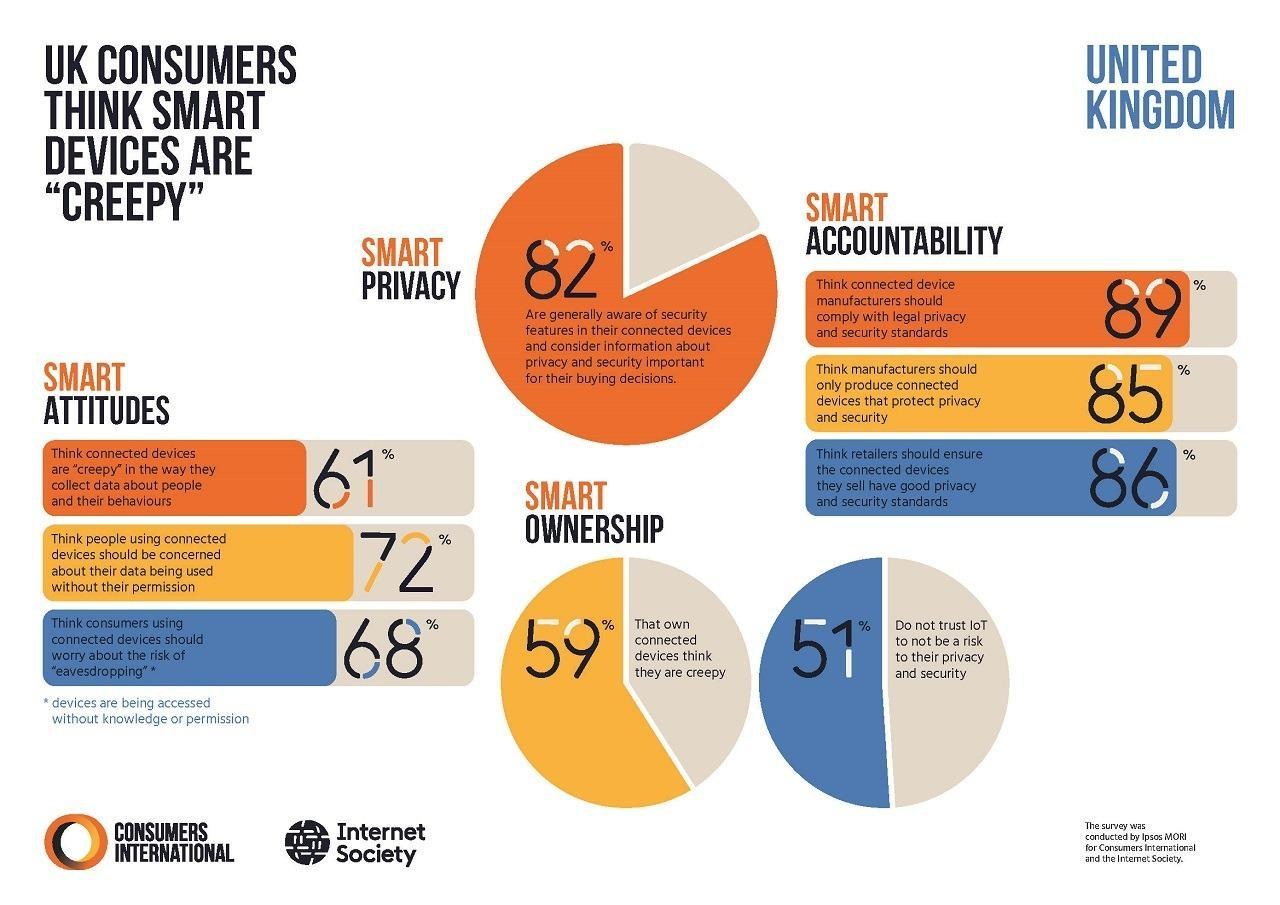What percentage of UK consumers think that the retailers should not ensure about the good privacy & security standards of the connected devices they sell?
Answer the question with a short phrase. 14% What percentage of UK consumers think that people using connected devices should not be concerned about their data being used without their permission? 28% What percentage of UK consumers who own connected devices didn't think they are creepy? 41% What percentage of UK consumers think that the connected device manufacturers should not comply with the legal privacy & security standards? 11% 